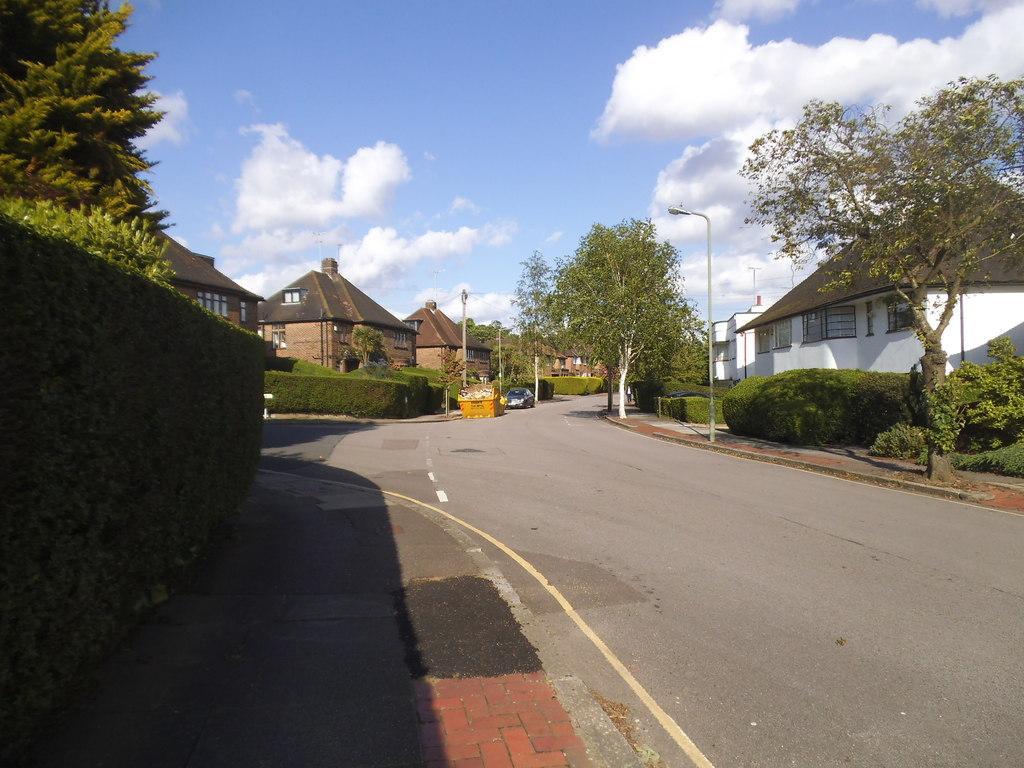Describe this image in one or two sentences. In this image I can see the vehicle on the road and I can see few trees in green color, few light poles and few buildings in brown and white color and the sky is in blue and white color. 